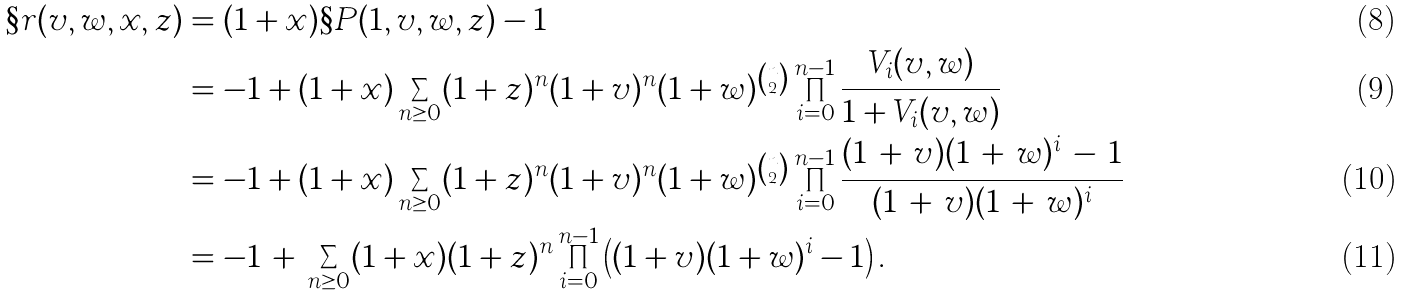Convert formula to latex. <formula><loc_0><loc_0><loc_500><loc_500>\S r ( v , w , x , z ) & = ( 1 + x ) \S P ( 1 , v , w , z ) - 1 \\ & = - 1 + ( 1 + x ) \sum _ { n \geq 0 } ( 1 + z ) ^ { n } ( 1 + v ) ^ { n } ( 1 + w ) ^ { \binom { n } { 2 } } \prod _ { i = 0 } ^ { n - 1 } \frac { V _ { i } ( v , w ) } { 1 + V _ { i } ( v , w ) } \\ & = - 1 + ( 1 + x ) \sum _ { n \geq 0 } ( 1 + z ) ^ { n } ( 1 + v ) ^ { n } ( 1 + w ) ^ { \binom { n } { 2 } } \prod _ { i = 0 } ^ { n - 1 } \frac { ( 1 \, + \, v ) ( 1 \, + \, w ) ^ { i } \, - \, 1 } { ( 1 \, + \, v ) ( 1 \, + \, w ) ^ { i } } \\ & = - 1 \, + \, \sum _ { n \geq 0 } ( 1 + x ) ( 1 + z ) ^ { n } \prod _ { i = 0 } ^ { n - 1 } \left ( ( 1 + v ) ( 1 + w ) ^ { i } - 1 \right ) .</formula> 